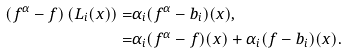<formula> <loc_0><loc_0><loc_500><loc_500>( f ^ { \alpha } - f ) \left ( L _ { i } ( x ) \right ) = & \alpha _ { i } ( f ^ { \alpha } - b _ { i } ) ( x ) , \\ = & \alpha _ { i } ( f ^ { \alpha } - f ) ( x ) + \alpha _ { i } ( f - b _ { i } ) ( x ) .</formula> 